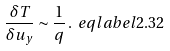Convert formula to latex. <formula><loc_0><loc_0><loc_500><loc_500>\frac { \delta T } { \delta u _ { y } } \sim \frac { 1 } { q } \, . \ e q l a b e l { 2 . 3 2 }</formula> 